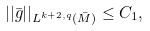<formula> <loc_0><loc_0><loc_500><loc_500>| | \bar { g } | | _ { L ^ { k + 2 , q } ( \bar { M } ) } \leq C _ { 1 } ,</formula> 